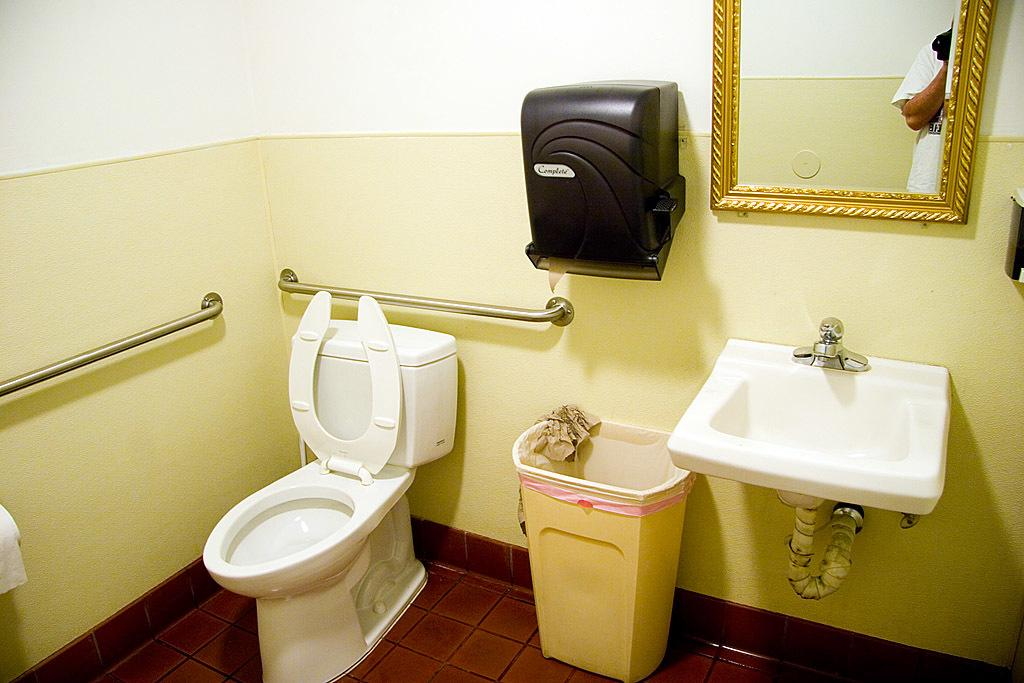What type of fixture is present in the image? There is a commode in the image. What is attached to the commode in the image? There is a flush tank attached to the commode in the image. What other fixture is present in the image? There is a wash basin in the image. What is used for disposing of waste in the image? There is a dust bin in the image for disposing of waste. What is used for drying hands in the image? There is a hand dryer in the image. What is present on the wall in the image? There is a mirror on the wall in the image. What can be seen in the mirror's reflection? The reflection of a person's hand is visible in the mirror. How much wealth is displayed in the image? There is no indication of wealth in the image; it features various fixtures in a bathroom setting. What type of crib is present in the image? There is no crib present in the image; it features bathroom fixtures. 